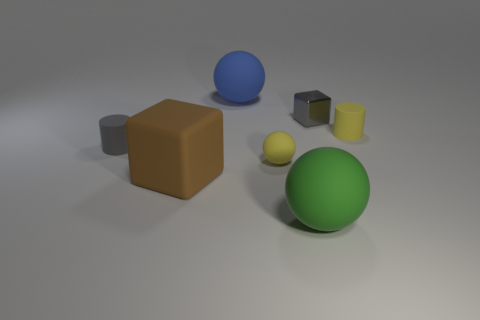Add 2 rubber things. How many objects exist? 9 Subtract all tiny matte spheres. How many spheres are left? 2 Subtract 1 spheres. How many spheres are left? 2 Add 3 tiny red objects. How many tiny red objects exist? 3 Subtract all blue balls. How many balls are left? 2 Subtract 0 purple cylinders. How many objects are left? 7 Subtract all cylinders. How many objects are left? 5 Subtract all green blocks. Subtract all brown cylinders. How many blocks are left? 2 Subtract all brown blocks. How many purple balls are left? 0 Subtract all tiny green shiny cylinders. Subtract all brown matte objects. How many objects are left? 6 